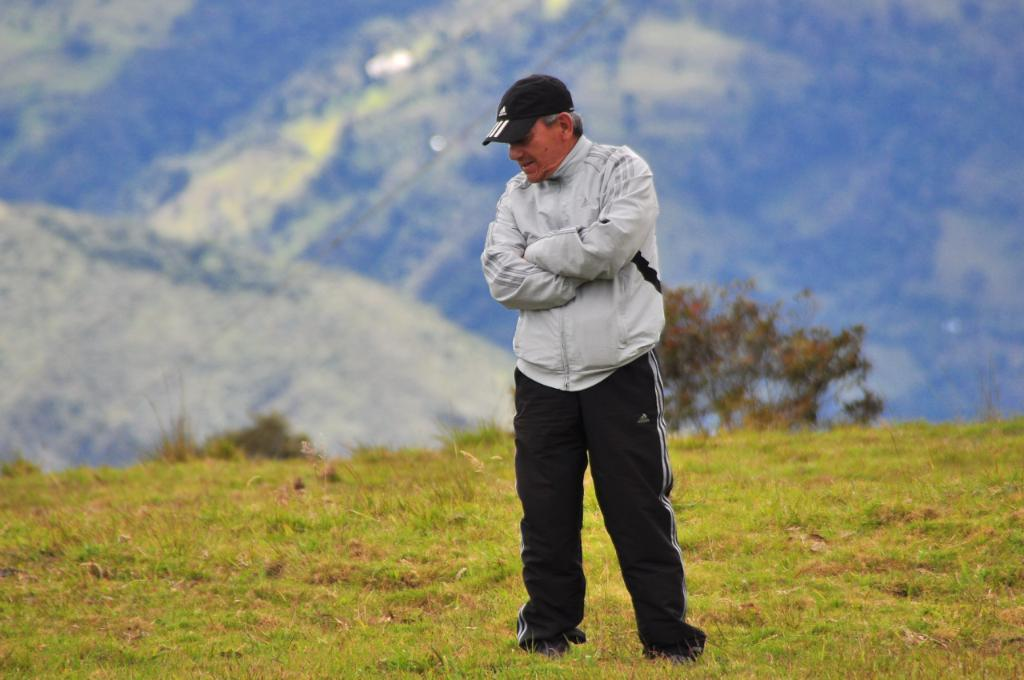What is the main subject of the image? There is a person standing in the image. What type of terrain is visible in the image? There is grass and plants in the image. What can be seen in the background of the image? Hills and the sky are visible in the background of the image. What type of drink is being held by the person in the image? There is no drink visible in the image; the person is not holding anything. How many fingers does the person have in the image? The number of fingers on the person's hand cannot be determined from the image. 